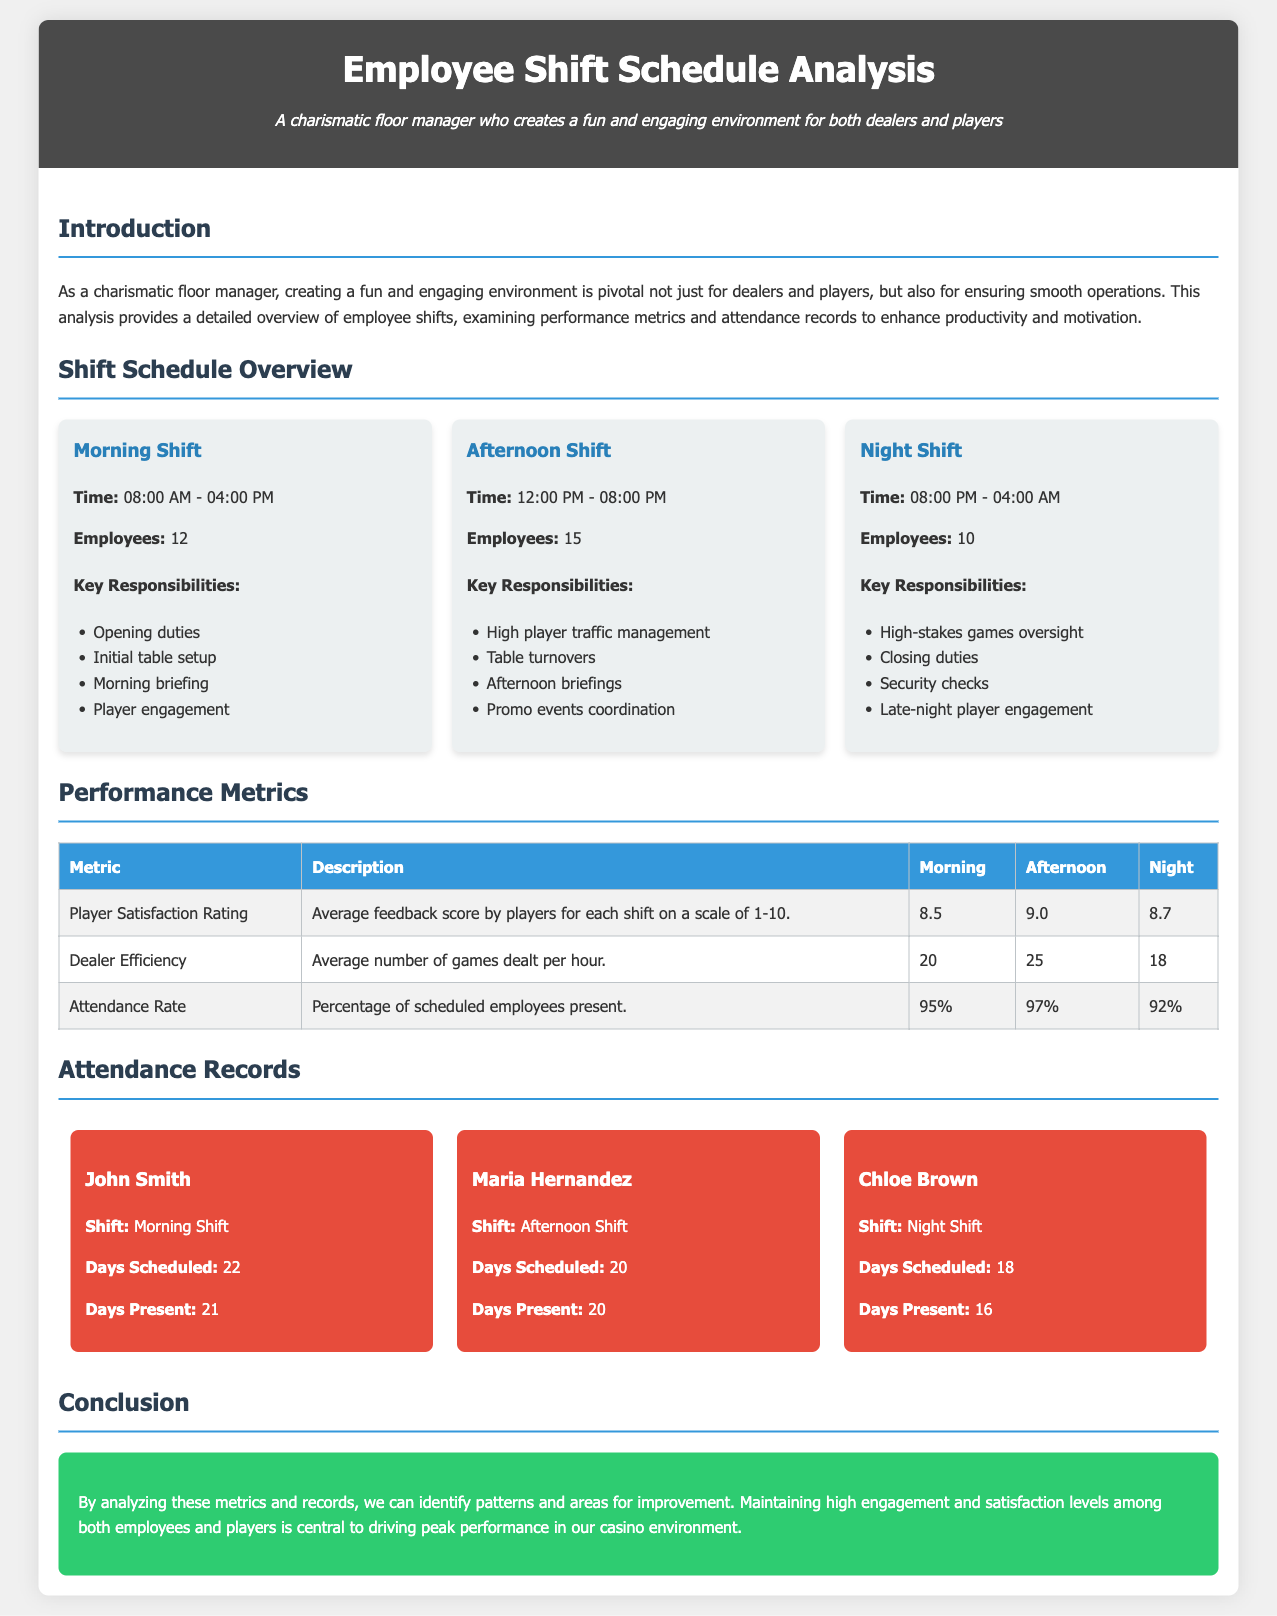what are the hours for the Morning Shift? The Morning Shift is scheduled from 08:00 AM to 04:00 PM as indicated in the shift schedule overview.
Answer: 08:00 AM - 04:00 PM how many employees work the Afternoon Shift? The document specifies that there are 15 employees assigned to the Afternoon Shift.
Answer: 15 what is the Player Satisfaction Rating for the Night Shift? The Player Satisfaction Rating for the Night Shift is listed in the performance metrics section of the document.
Answer: 8.7 which employee has the highest attendance in their shift? Comparing the attendance records, Maria Hernandez attended all scheduled days of her shift.
Answer: Maria Hernandez what is the Attendance Rate for the Morning Shift? The Attendance Rate for the Morning Shift is mentioned in the performance metrics section.
Answer: 95% what are the core responsibilities of employees during the Night Shift? The document outlines key responsibilities for the Night Shift, including high-stakes games oversight and closing duties.
Answer: High-stakes games oversight how many games do dealers average per hour during the Afternoon Shift? The document shows that dealers average 25 games per hour during the Afternoon Shift.
Answer: 25 what is the conclusion regarding employee and player engagement? The conclusion highlights the importance of maintaining high engagement and satisfaction levels among employees and players to enhance performance.
Answer: Central to driving peak performance 